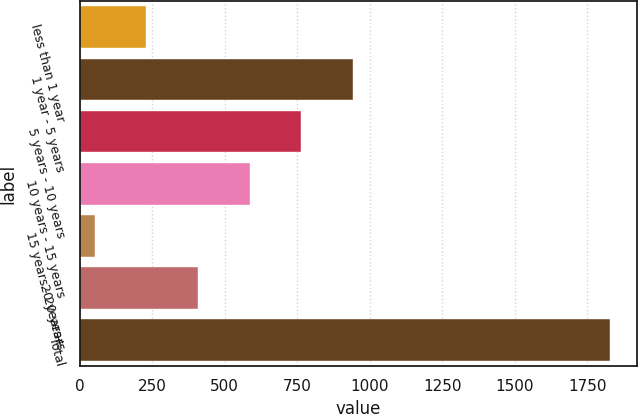Convert chart. <chart><loc_0><loc_0><loc_500><loc_500><bar_chart><fcel>less than 1 year<fcel>1 year - 5 years<fcel>5 years - 10 years<fcel>10 years - 15 years<fcel>15 years - 20 years<fcel>20 years+<fcel>Total<nl><fcel>229.8<fcel>941<fcel>763.2<fcel>585.4<fcel>52<fcel>407.6<fcel>1830<nl></chart> 